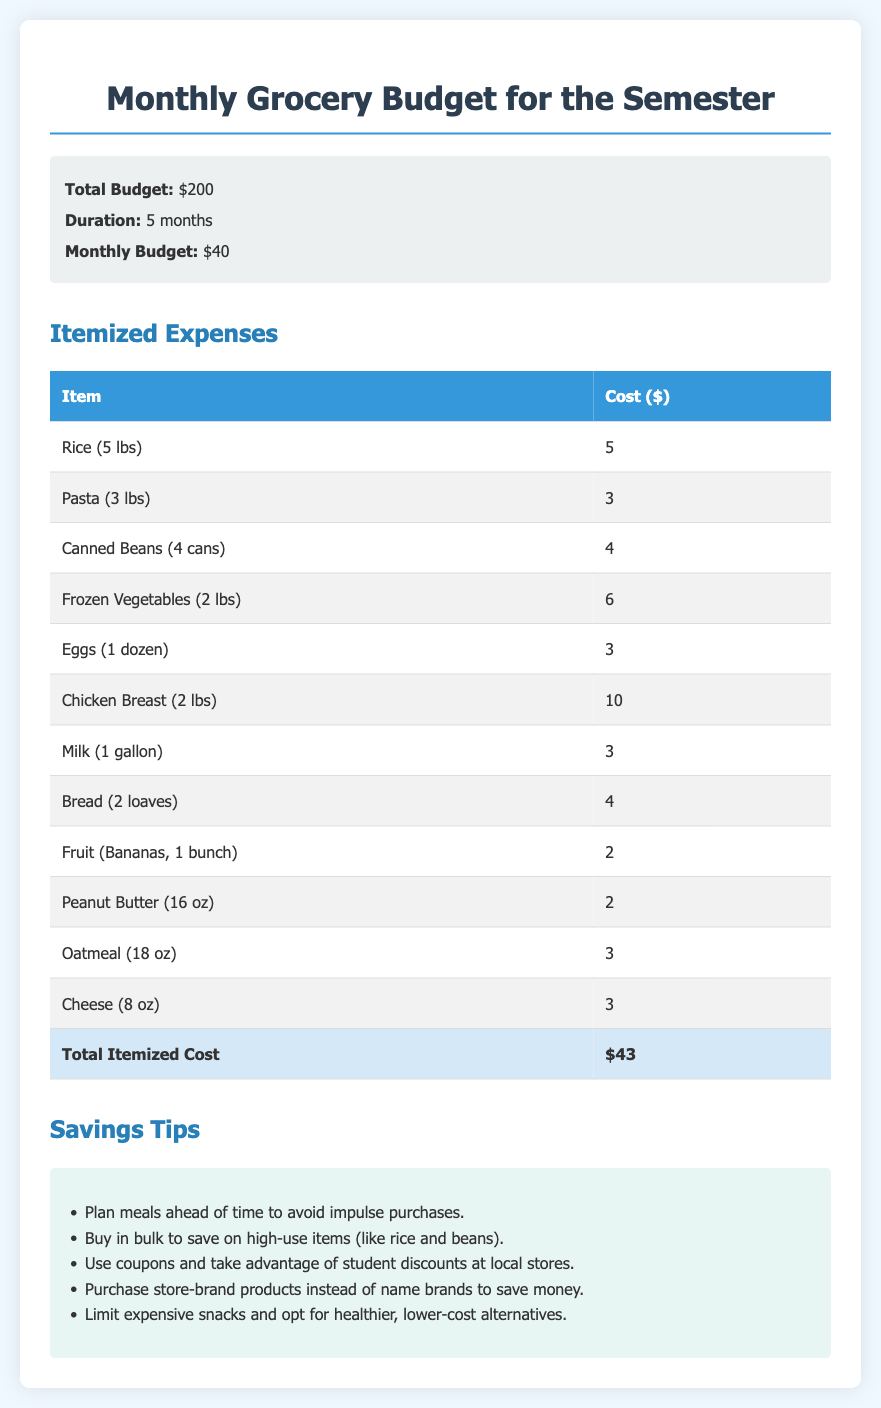what is the total monthly budget? The total monthly budget is detailed in the document as $40.
Answer: $40 how many months does the budget cover? The duration of the budget, as stated, is 5 months.
Answer: 5 months what is the cost of chicken breast? The cost of chicken breast, listed in the expenses, is $10.
Answer: $10 what is the total itemized cost? The total itemized cost is summarized at the end of the expense table as $43.
Answer: $43 which item has the lowest cost? The item with the lowest cost in the list is Peanut Butter at $2.
Answer: $2 how many tips are provided for saving? The document contains 5 tips for saving on groceries.
Answer: 5 tips what is one savings tip mentioned? One savings tip provided is to buy in bulk to save on high-use items.
Answer: Buy in bulk what is the cost of canned beans? The cost of canned beans is specified to be $4.
Answer: $4 what is the total budget? The total budget refers to the sum allocated for the semester, which is $200.
Answer: $200 